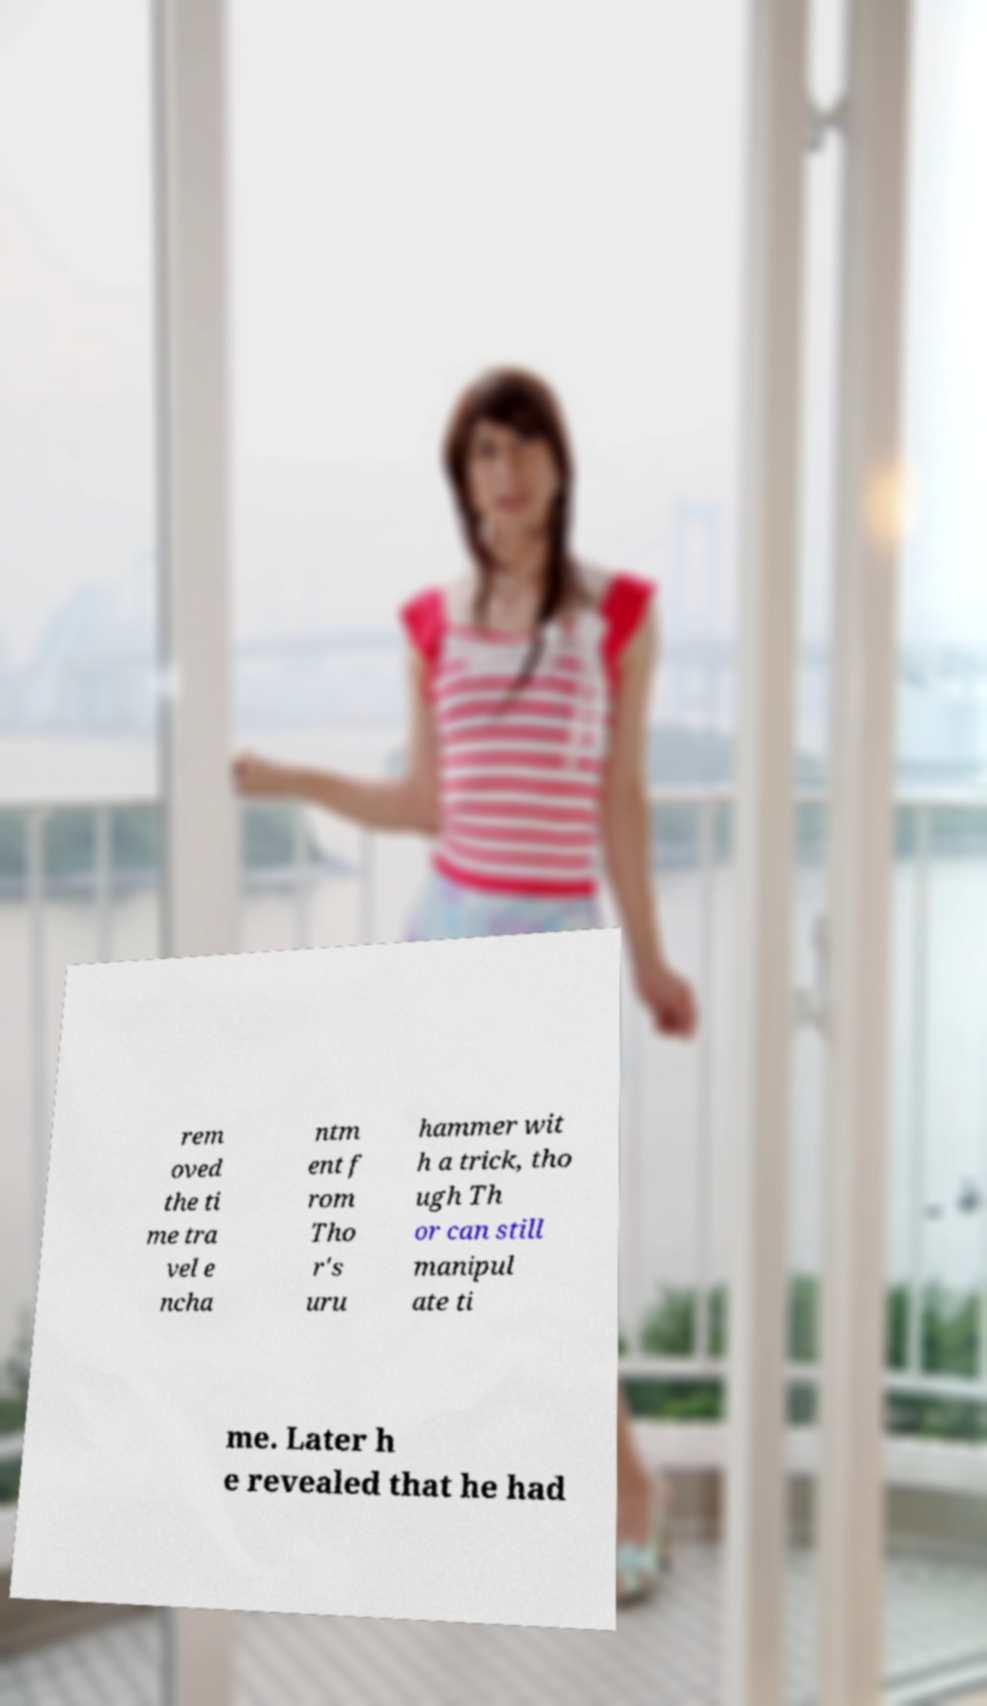Can you accurately transcribe the text from the provided image for me? rem oved the ti me tra vel e ncha ntm ent f rom Tho r's uru hammer wit h a trick, tho ugh Th or can still manipul ate ti me. Later h e revealed that he had 